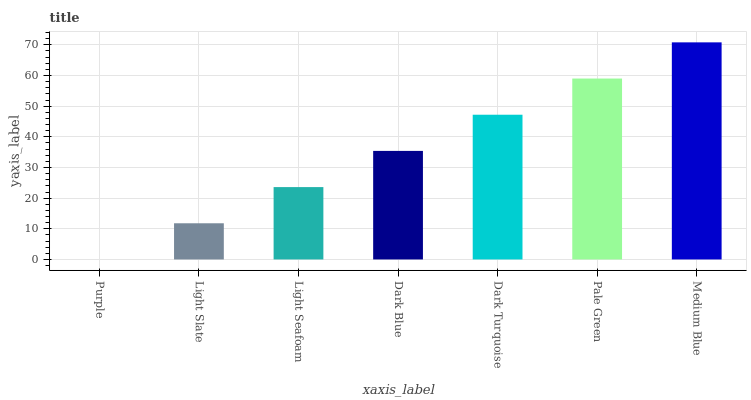Is Purple the minimum?
Answer yes or no. Yes. Is Medium Blue the maximum?
Answer yes or no. Yes. Is Light Slate the minimum?
Answer yes or no. No. Is Light Slate the maximum?
Answer yes or no. No. Is Light Slate greater than Purple?
Answer yes or no. Yes. Is Purple less than Light Slate?
Answer yes or no. Yes. Is Purple greater than Light Slate?
Answer yes or no. No. Is Light Slate less than Purple?
Answer yes or no. No. Is Dark Blue the high median?
Answer yes or no. Yes. Is Dark Blue the low median?
Answer yes or no. Yes. Is Medium Blue the high median?
Answer yes or no. No. Is Pale Green the low median?
Answer yes or no. No. 